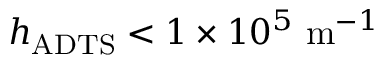<formula> <loc_0><loc_0><loc_500><loc_500>h _ { A D T S } < 1 \times 1 0 ^ { 5 } \ m ^ { - 1 }</formula> 